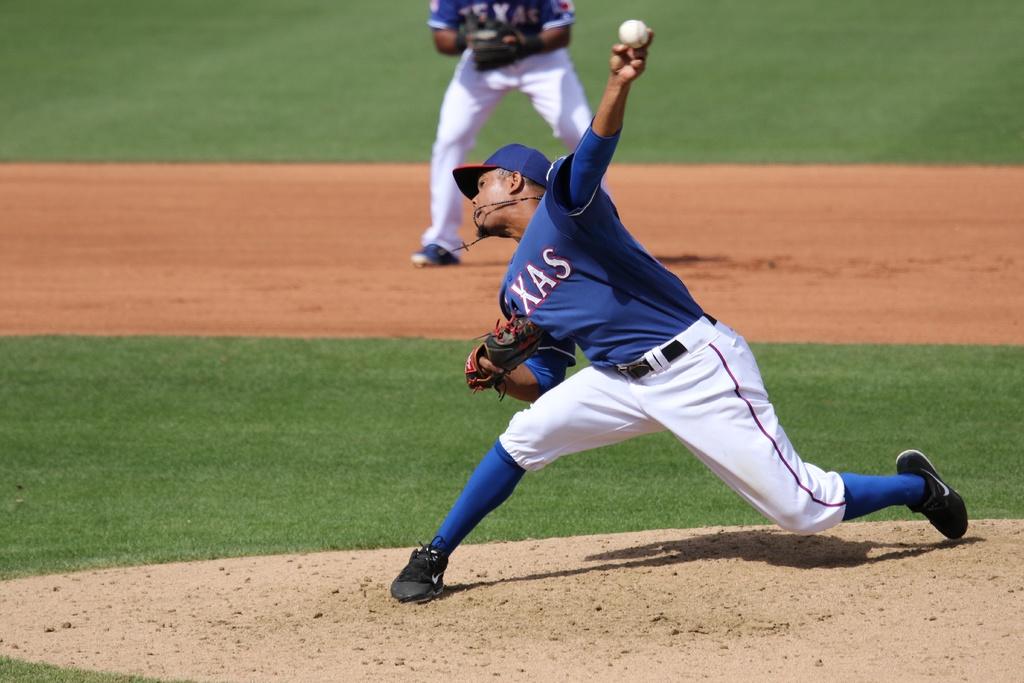What team does he pitcher play for?
Your answer should be very brief. Texas. 